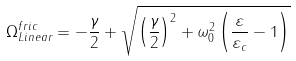<formula> <loc_0><loc_0><loc_500><loc_500>\Omega _ { L i n e a r } ^ { f r i c } = - \frac { \gamma } { 2 } + \sqrt { \left ( \frac { \gamma } { 2 } \right ) ^ { 2 } + \omega _ { 0 } ^ { 2 } \left ( \frac { \varepsilon } { \varepsilon _ { c } } - 1 \right ) }</formula> 